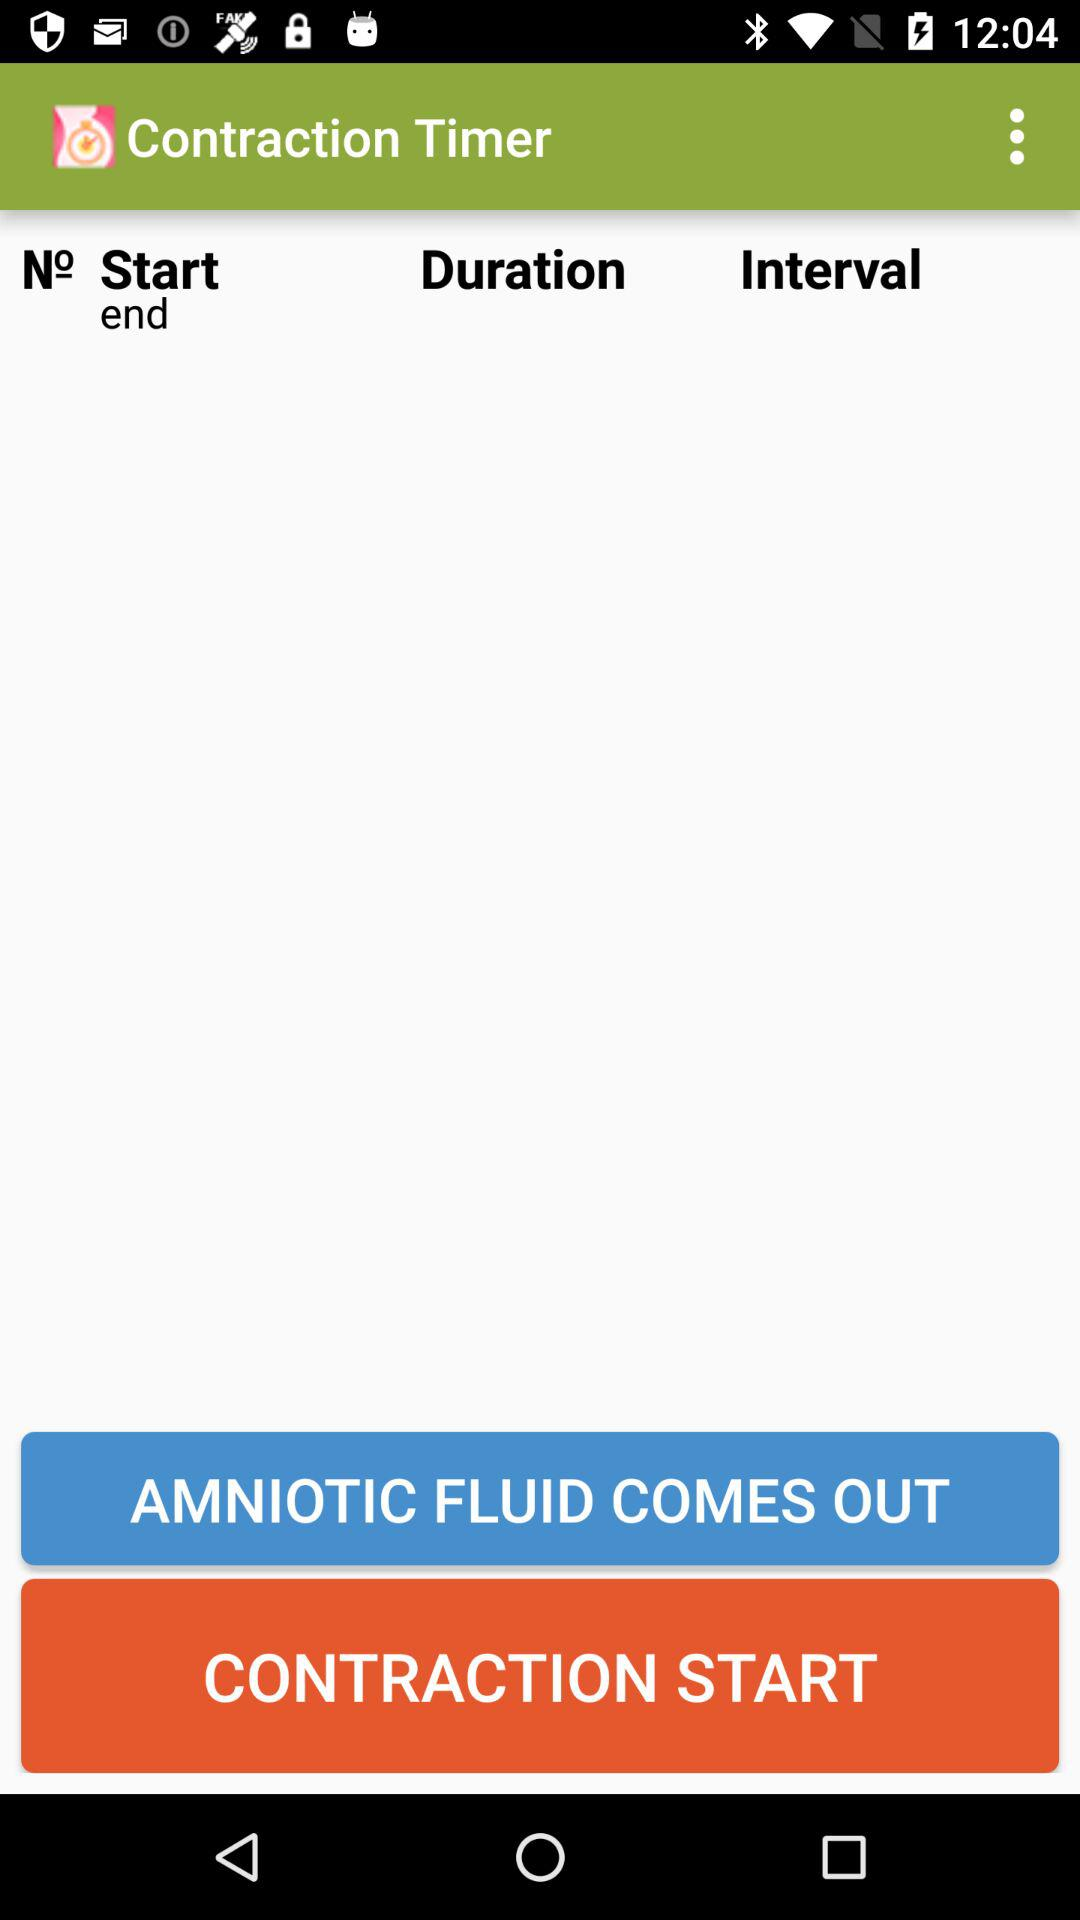What is the name of the application? The name of the application is "Contraction Timer". 